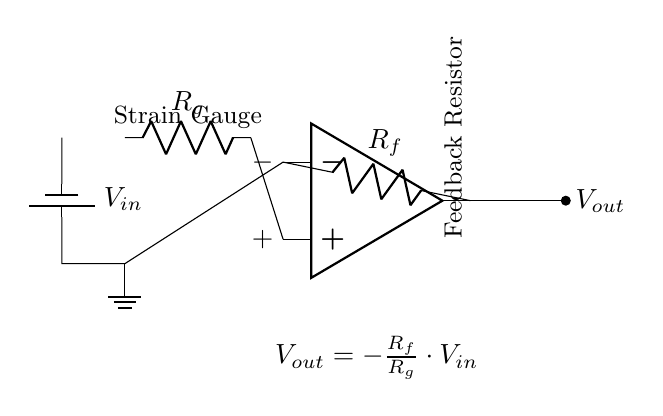What type of operational amplifier configuration is shown in the circuit? The circuit represents an inverting amplifier configuration, which can be identified by the feedback resistor connected between the output and the inverting terminal of the operational amplifier.
Answer: Inverting amplifier What does the resistor labeled Rg represent in the circuit? The resistor labeled Rg indicates the strain gauge, which is a device that changes resistance when elongated or compressed due to strain experienced by structures, thereby affecting the input signal to the amplifier.
Answer: Strain gauge What is the relationship represented by the equation in the circuit diagram? The equation indicates that the output voltage is proportional to the input voltage scaled by the ratio of the feedback resistor to the strain gauge resistor, showing how amplification occurs in response to input changes.
Answer: Output voltage proportional to input voltage ratio What is the output voltage of the circuit if Rg is 100 ohms, Rf is 1000 ohms, and Vin is 5 volts? Using the formula provided, Vout = - (Rf/Rg) * Vin, substituting the values gives Vout = - (1000/100) * 5 = -50 volts, which illustrates how the circuit amplifies and inverts the input signal.
Answer: Negative fifty volts What is the effect of increasing the feedback resistor Rf on the output voltage? Increasing the feedback resistor Rf increases the gain of the inverting amplifier, which means for the same input voltage, the magnitude of the output voltage will increase while still being inverted.
Answer: Increased output voltage magnitude What are the terminals labeled '+' and '-' on the operational amplifier used for? The '+' terminal is the non-inverting input, while the '-' terminal is the inverting input; the operation of the amplifier depends on the application of input signals at these terminals to determine the output behavior.
Answer: Non-inverting and inverting inputs 